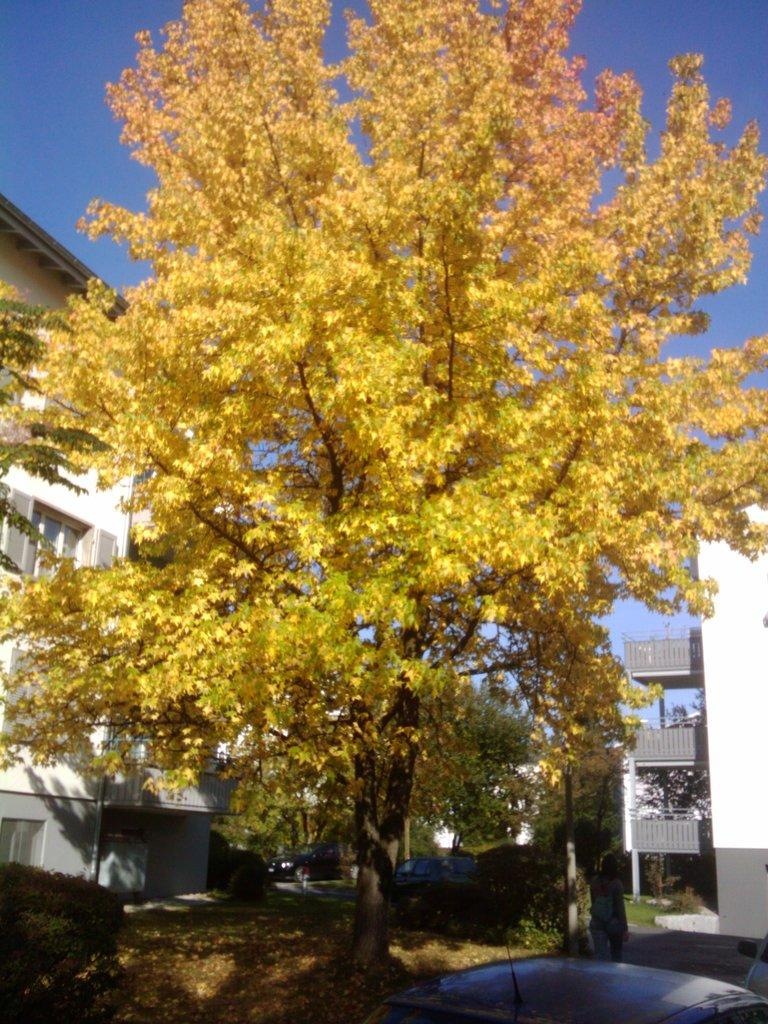What type of plant can be seen in the image? There is a tree in the image. What is the color of the tree? The tree is yellow in color. What type of structures are visible in the image? There are buildings in the image. What colors are the buildings? The buildings are white and grey in color. What can be seen in the sky in the image? The sky is blue in the image. Can you see any cheese in the image? There is no cheese present in the image. 